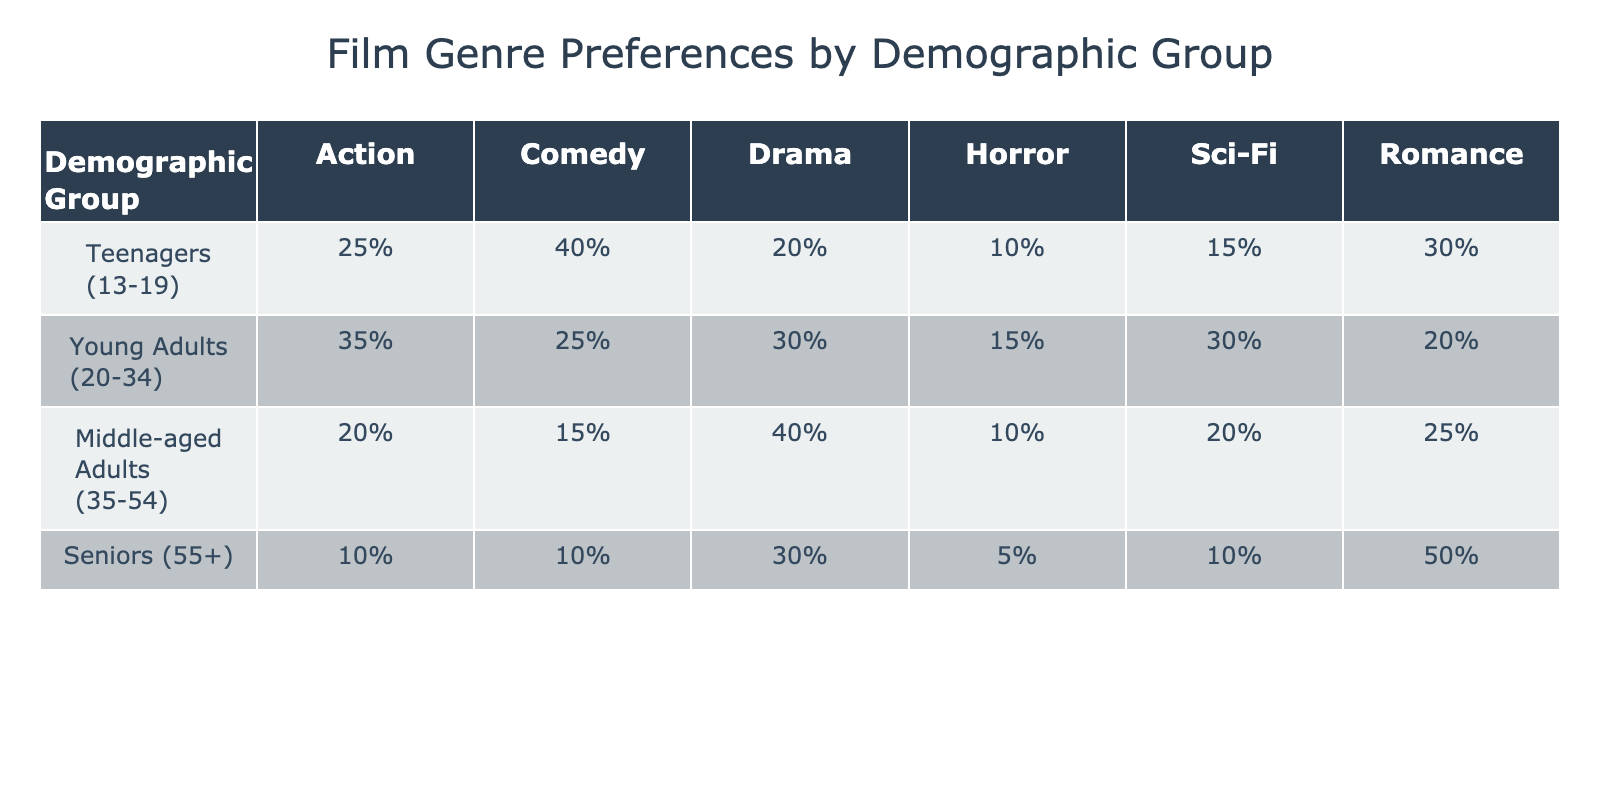What percentage of seniors prefer Romance films? In the table, under the "Seniors (55+)" demographic group, the percentage for Romance films is listed as "50%."
Answer: 50% Which demographic group has the highest preference for Action films? Looking at the Action film preferences, the highest percentage is "35%" for the "Young Adults (20-34)" demographic group.
Answer: Young Adults (20-34) What is the sum of the preferences for Horror films across all demographic groups? The preferences for Horror films are: Teenagers (10%), Young Adults (15%), Middle-aged Adults (10%), and Seniors (5%). Adding these percentages gives 10 + 15 + 10 + 5 = 40.
Answer: 40% Is it true that Drama films are more popular among Middle-aged Adults than among Young Adults? For Middle-aged Adults, Drama preferences are at "40%," while for Young Adults, it is "30%." Since 40% is greater than 30%, the statement is true.
Answer: Yes Which genre do Teenagers have the lowest preference for, and what is that percentage? In the table, Teenagers have preferences of "25%" for Action, "40%" for Comedy, "20%" for Drama, "10%" for Horror, "15%" for Sci-Fi, and "30%" for Romance. The lowest is "10%" for Horror.
Answer: Horror, 10% If the Romance preference among Seniors is excluded, what is the average percentage preference for the remaining genres in that demographic? For Seniors, the preferences for the other genres are Action (10%), Comedy (10%), Drama (30%), Horror (5%), and Sci-Fi (10%). The sum is 10 + 10 + 30 + 5 + 10 = 65. There are 5 genres, so the average is 65/5 = 13.
Answer: 13% How does the preference for Comedy films among Young Adults compare to that of Middle-aged Adults? Young Adults have a preference of "25%" for Comedy, while Middle-aged Adults have "15%." Comparing these values, 25% is greater than 15%, indicating Young Adults prefer Comedy films more.
Answer: Young Adults prefer more For which genre do both Young Adults and Teenagers have similar preference percentages? The percentages for Action are 35% for Young Adults and 25% for Teenagers. For Sci-Fi, the percentages are 30% for both groups. This is the only genre where they have similar preferences.
Answer: Sci-Fi What is the difference in preference percentages for Drama films between Middle-aged Adults and Seniors? Middle-aged Adults prefer Drama at "40%" while Seniors prefer it at "30%." The difference is calculated as 40% - 30%, resulting in a 10% difference.
Answer: 10% 